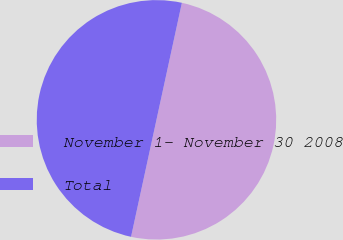Convert chart. <chart><loc_0><loc_0><loc_500><loc_500><pie_chart><fcel>November 1- November 30 2008<fcel>Total<nl><fcel>50.0%<fcel>50.0%<nl></chart> 